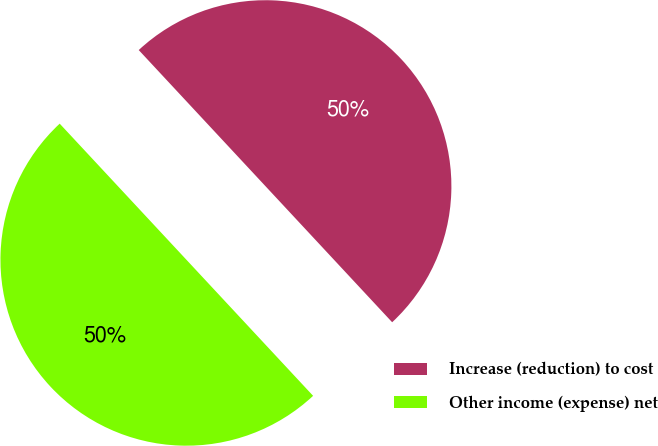Convert chart to OTSL. <chart><loc_0><loc_0><loc_500><loc_500><pie_chart><fcel>Increase (reduction) to cost<fcel>Other income (expense) net<nl><fcel>50.0%<fcel>50.0%<nl></chart> 